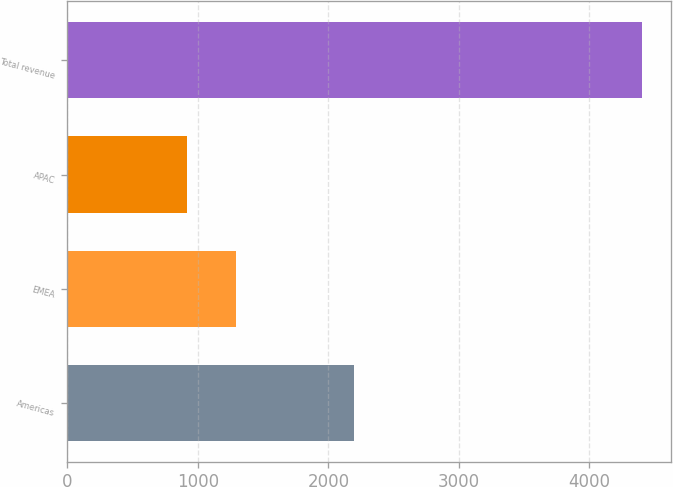Convert chart. <chart><loc_0><loc_0><loc_500><loc_500><bar_chart><fcel>Americas<fcel>EMEA<fcel>APAC<fcel>Total revenue<nl><fcel>2196.4<fcel>1294.6<fcel>912.7<fcel>4403.7<nl></chart> 